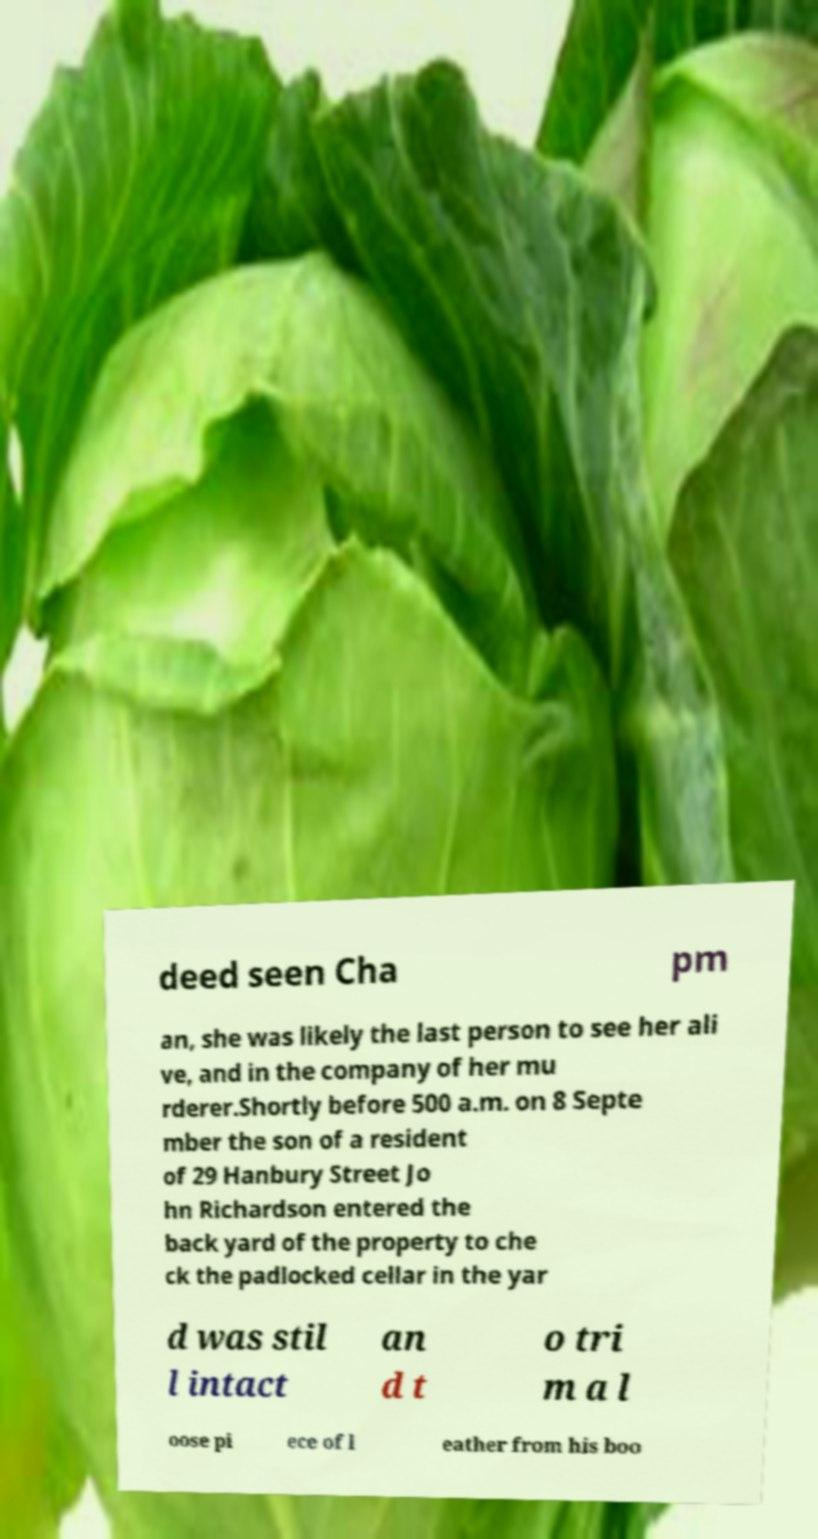Please read and relay the text visible in this image. What does it say? deed seen Cha pm an, she was likely the last person to see her ali ve, and in the company of her mu rderer.Shortly before 500 a.m. on 8 Septe mber the son of a resident of 29 Hanbury Street Jo hn Richardson entered the back yard of the property to che ck the padlocked cellar in the yar d was stil l intact an d t o tri m a l oose pi ece of l eather from his boo 